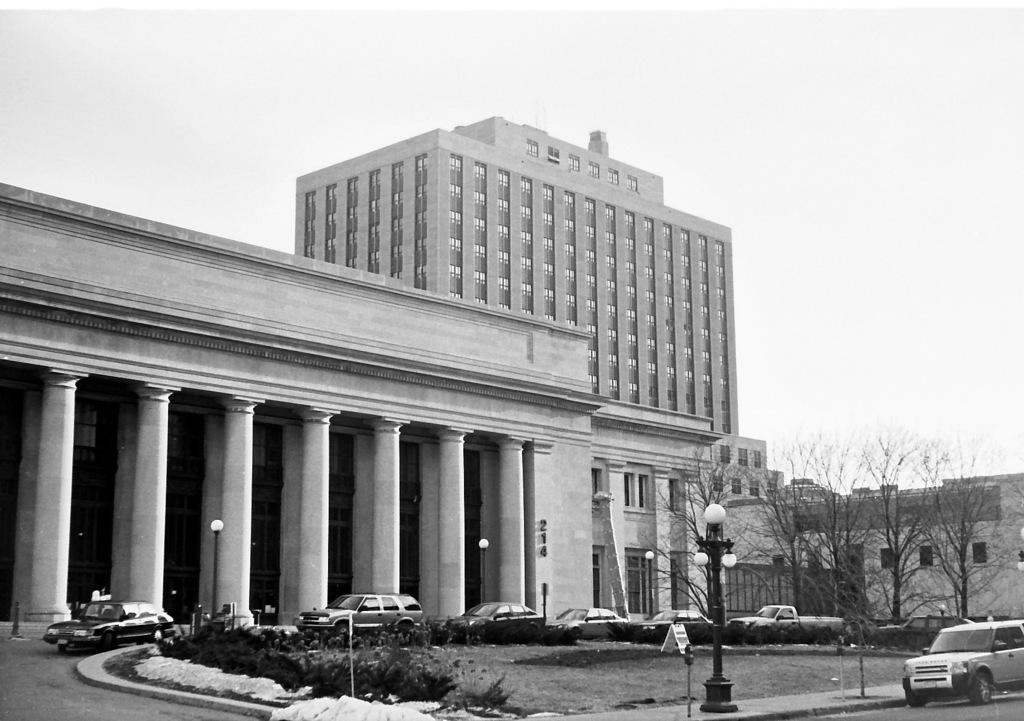What type of structure is present in the image? There is a building in the image. What mode of transportation can be seen on the road in the image? There are cars on the road in the image. What are the vertical structures visible in the image? There are poles visible in the image. What type of vegetation is present in the image? There are trees and plants on the ground in the image. What part of the natural environment is visible in the background of the image? The sky is visible in the background of the image. What type of knee is visible on the building in the image? There is no knee present on the building in the image. What is the process of making bricks in the image? There is no process of making bricks depicted in the image. 